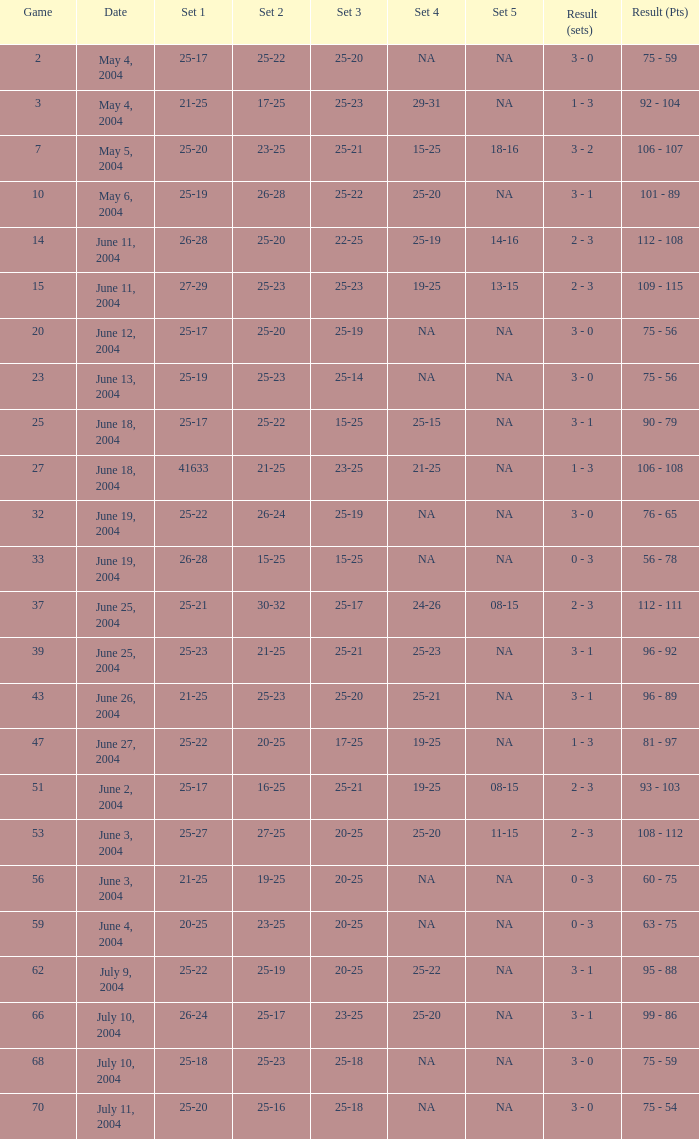What is the result of the game with a set 1 of 26-24? 99 - 86. 